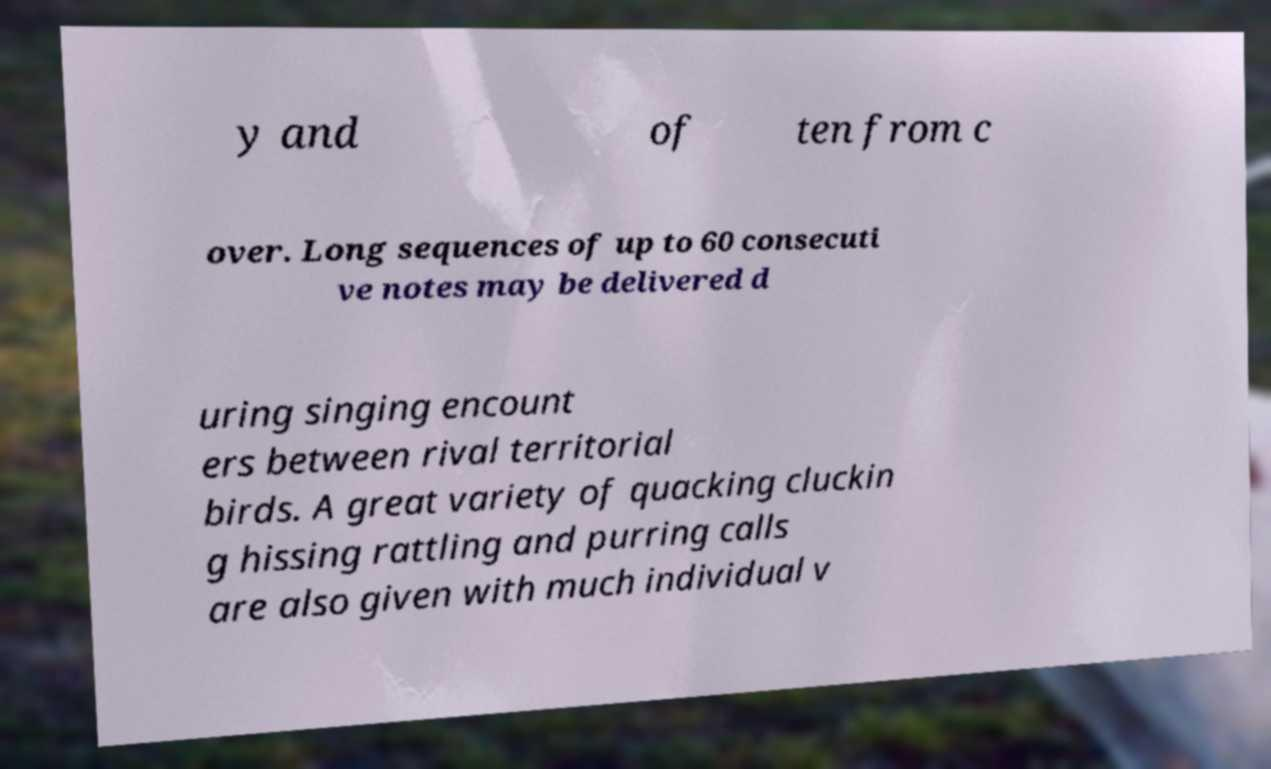Could you extract and type out the text from this image? y and of ten from c over. Long sequences of up to 60 consecuti ve notes may be delivered d uring singing encount ers between rival territorial birds. A great variety of quacking cluckin g hissing rattling and purring calls are also given with much individual v 